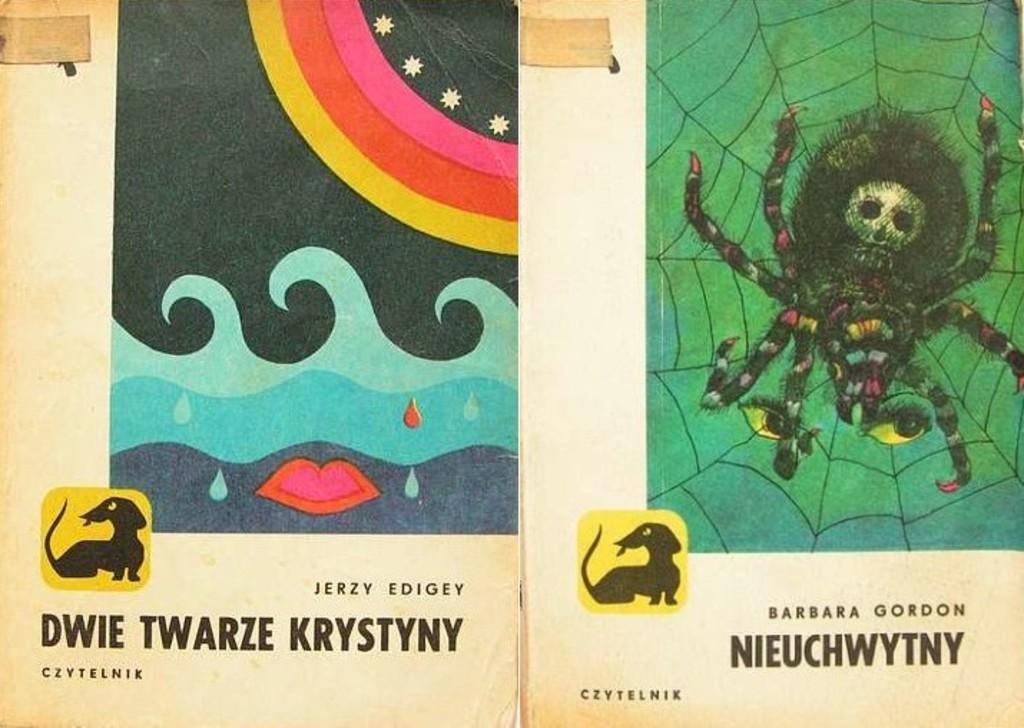What is depicted on the papers in the image? There are images on papers in the image. Can you describe the images on the papers? Unfortunately, the specific images on the papers cannot be determined from the provided facts. How much payment is being made in the image? There is no indication of payment being made in the image; it only shows images on papers. Is there a stream visible in the image? There is no mention of a stream or any other natural elements in the provided facts, so it cannot be determined if one is present in the image. 